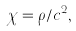<formula> <loc_0><loc_0><loc_500><loc_500>\chi = \rho / c ^ { 2 } ,</formula> 